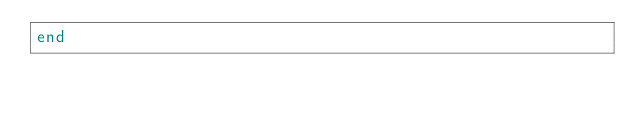Convert code to text. <code><loc_0><loc_0><loc_500><loc_500><_Ruby_>end
</code> 